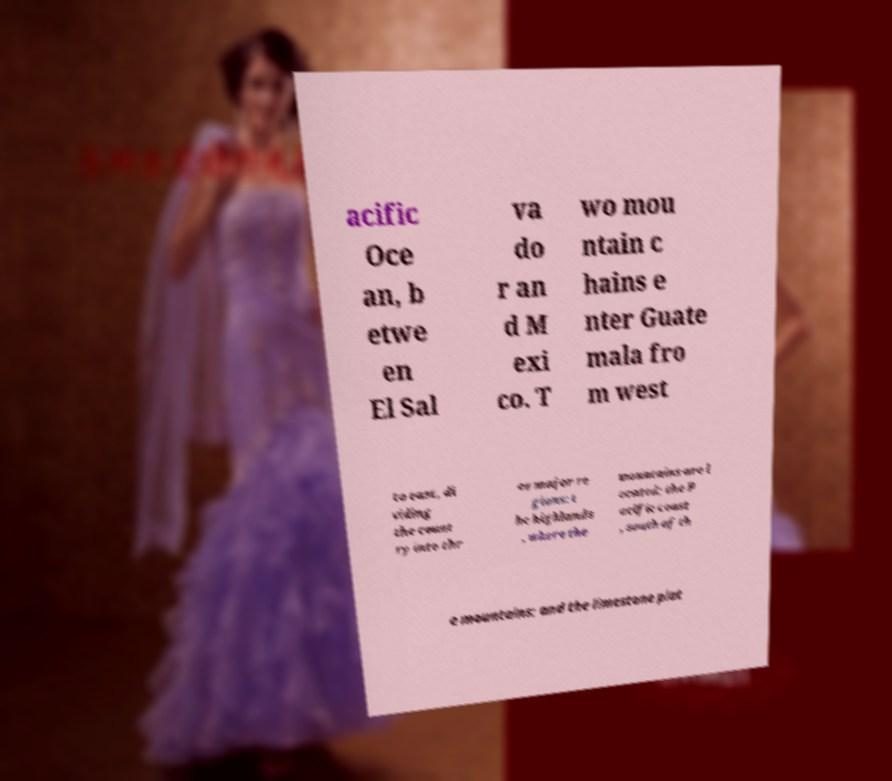I need the written content from this picture converted into text. Can you do that? acific Oce an, b etwe en El Sal va do r an d M exi co. T wo mou ntain c hains e nter Guate mala fro m west to east, di viding the count ry into thr ee major re gions: t he highlands , where the mountains are l ocated; the P acific coast , south of th e mountains; and the limestone plat 